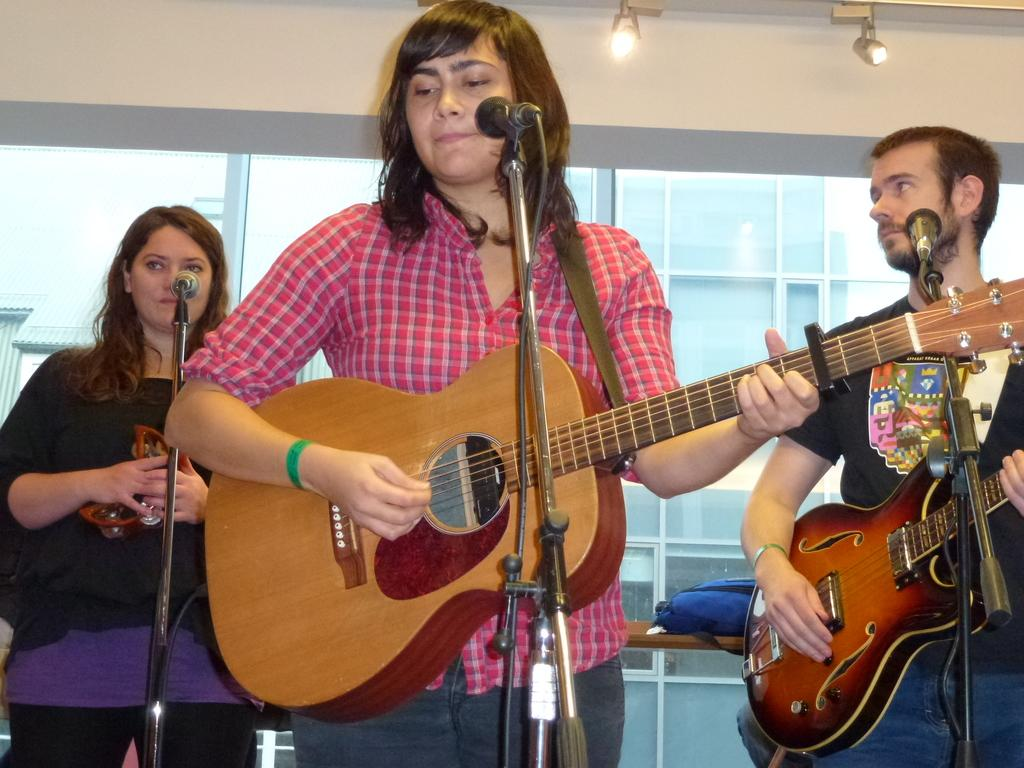How many people are in the image? There are three persons in the image. What are the persons doing in the image? The persons are standing and holding guitars. What object is in front of the persons? There is a microphone in front of the persons. Can you describe the background of the image? There is a wall, a light, a glass object, a table, and a backpack in the background of the image. What type of humor can be seen on the faces of the persons in the image? There is no indication of humor or facial expressions on the persons' faces in the image. What type of stretch can be seen in the image? There is no stretch or physical activity depicted in the image. 